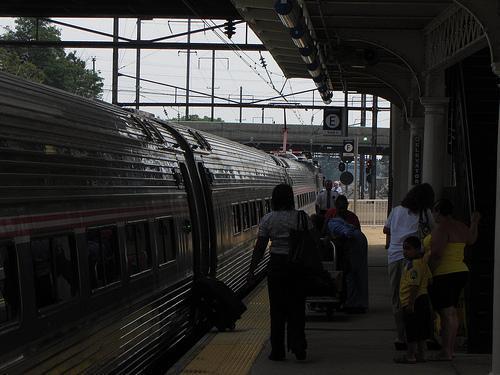How many people are there?
Give a very brief answer. 8. 